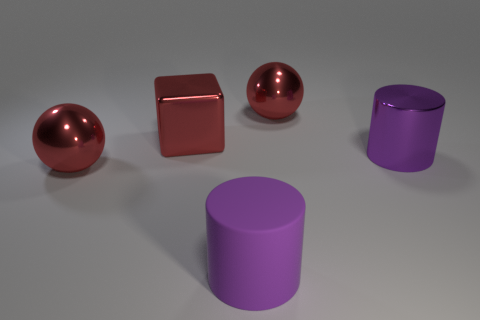What color is the cylinder that is the same material as the red cube?
Make the answer very short. Purple. What shape is the purple shiny thing?
Offer a very short reply. Cylinder. What is the large red ball behind the big metal block made of?
Your answer should be very brief. Metal. Is there a big metallic cylinder that has the same color as the large cube?
Make the answer very short. No. The purple metallic object that is the same size as the matte object is what shape?
Your response must be concise. Cylinder. What color is the large sphere on the left side of the big rubber cylinder?
Provide a short and direct response. Red. There is a big metal ball on the right side of the purple matte object; is there a purple thing that is right of it?
Make the answer very short. Yes. What number of things are large metallic balls that are left of the big rubber object or metallic things?
Provide a succinct answer. 4. There is a large ball that is in front of the red sphere right of the big purple rubber thing; what is it made of?
Provide a succinct answer. Metal. Are there the same number of large red shiny spheres that are left of the red metallic block and large red spheres right of the rubber object?
Provide a succinct answer. Yes. 